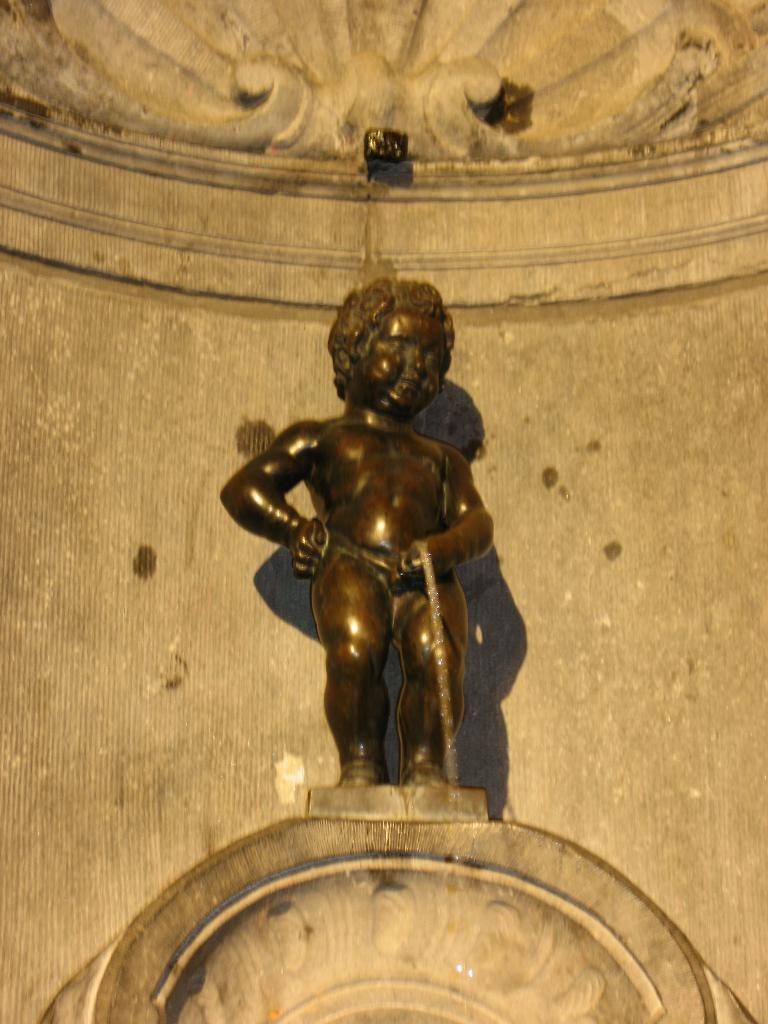What is the main subject in the middle of the image? There is a statue in the middle of the image. What type of guitar is the girl playing in the image? There is no guitar or girl present in the image; it only features a statue. 